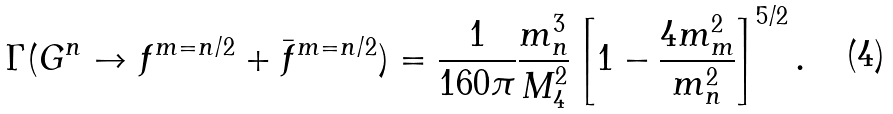Convert formula to latex. <formula><loc_0><loc_0><loc_500><loc_500>\Gamma ( G ^ { n } \to f ^ { m = n / 2 } + \bar { f } ^ { m = n / 2 } ) = \frac { 1 } { 1 6 0 \pi } \frac { m _ { n } ^ { 3 } } { M _ { 4 } ^ { 2 } } \left [ 1 - \frac { 4 m _ { m } ^ { 2 } } { m _ { n } ^ { 2 } } \right ] ^ { 5 / 2 } .</formula> 